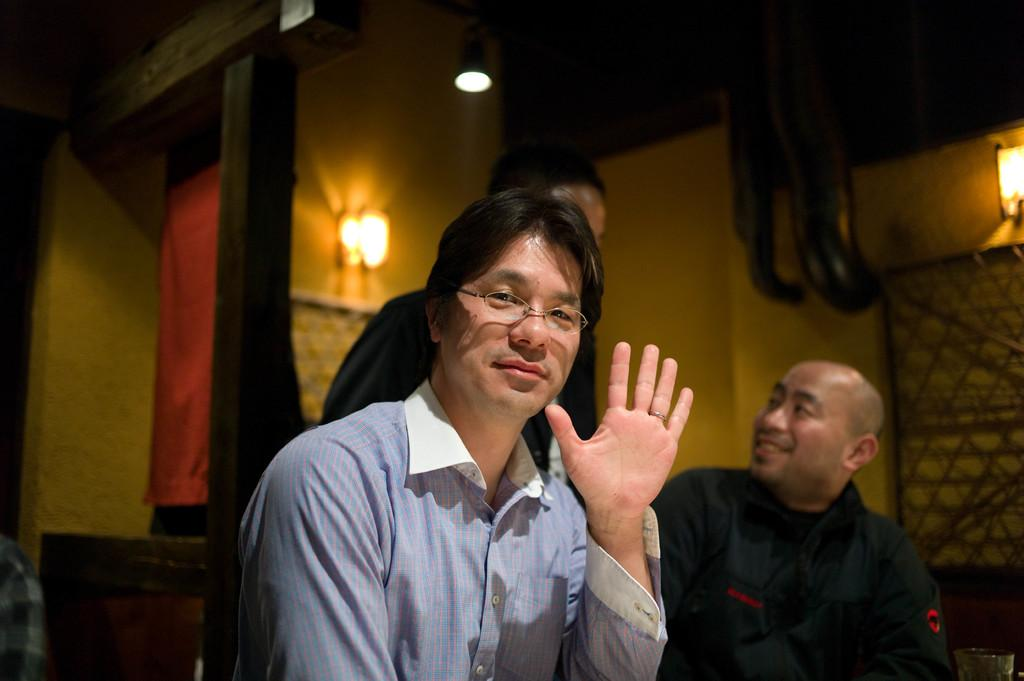How many people are in the image? There are three persons in the image. What is one person doing with his hand? One person is showing his hand. What activity is happening between two of the persons? Another person is talking to another person. Can you describe the lamp in the image? There is a lamp in the image, and it is glowing. What type of horn is attached to the governor in the image? There is no governor or horn present in the image. What is the chain used for in the image? There is no chain present in the image. 